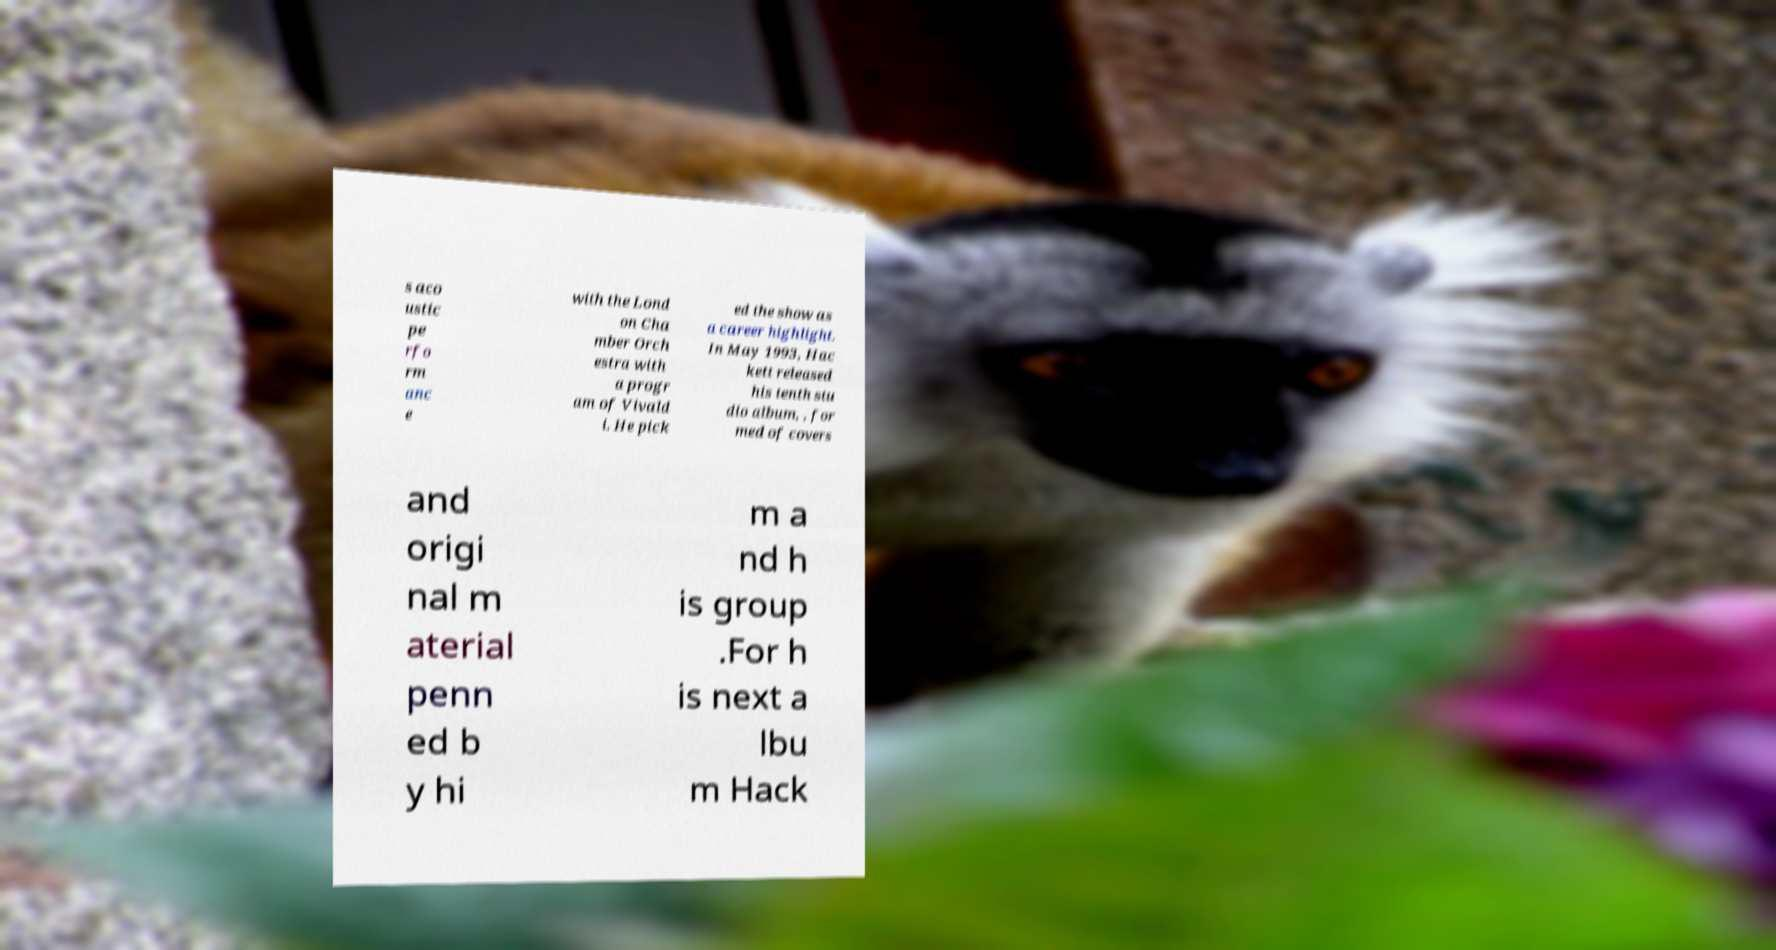What messages or text are displayed in this image? I need them in a readable, typed format. s aco ustic pe rfo rm anc e with the Lond on Cha mber Orch estra with a progr am of Vivald i. He pick ed the show as a career highlight. In May 1993, Hac kett released his tenth stu dio album, , for med of covers and origi nal m aterial penn ed b y hi m a nd h is group .For h is next a lbu m Hack 